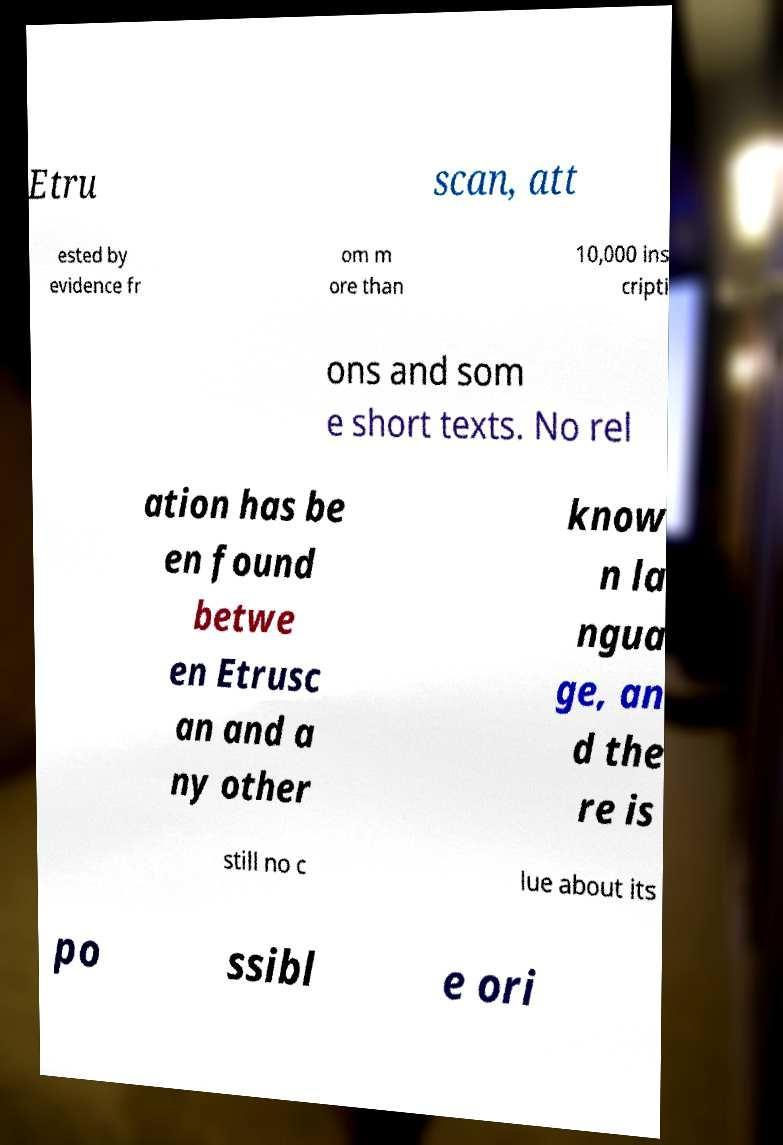I need the written content from this picture converted into text. Can you do that? Etru scan, att ested by evidence fr om m ore than 10,000 ins cripti ons and som e short texts. No rel ation has be en found betwe en Etrusc an and a ny other know n la ngua ge, an d the re is still no c lue about its po ssibl e ori 